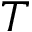<formula> <loc_0><loc_0><loc_500><loc_500>T</formula> 